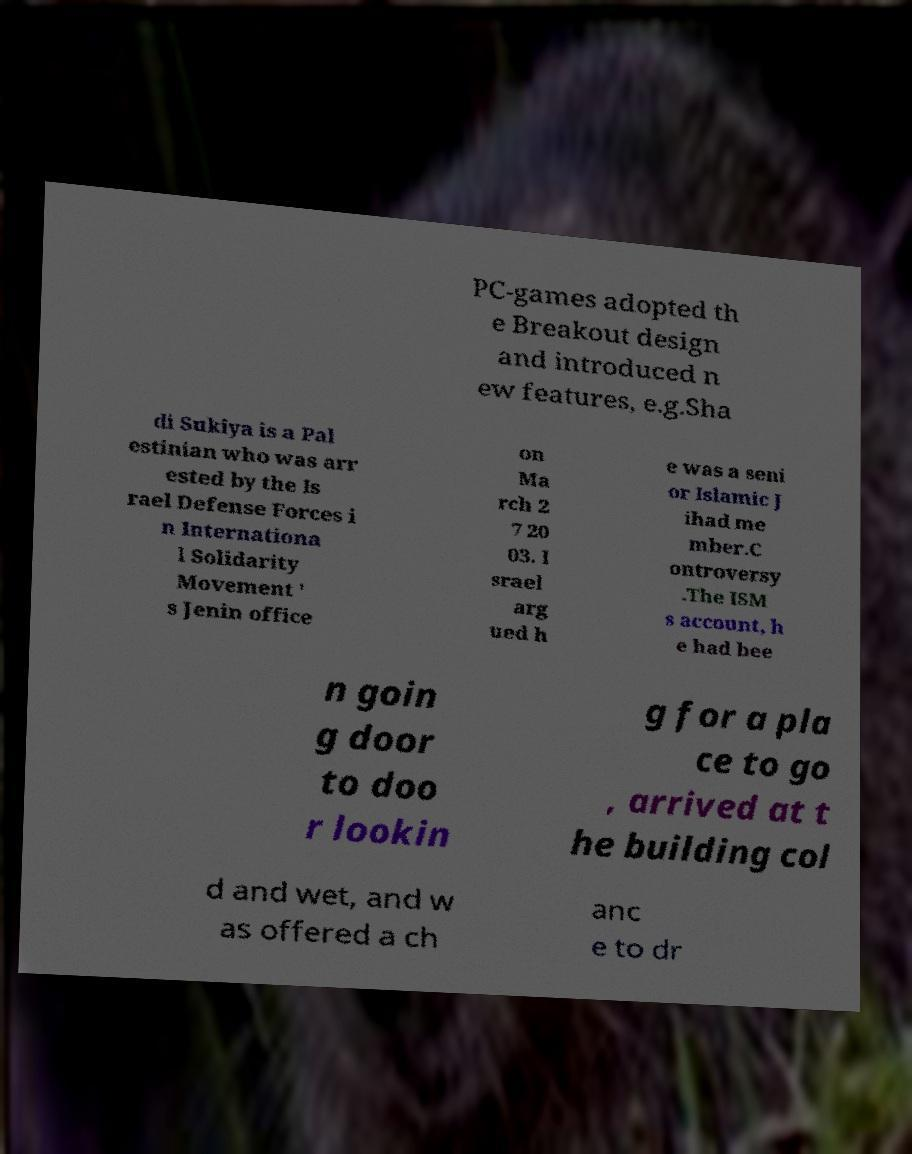What messages or text are displayed in this image? I need them in a readable, typed format. PC-games adopted th e Breakout design and introduced n ew features, e.g.Sha di Sukiya is a Pal estinian who was arr ested by the Is rael Defense Forces i n Internationa l Solidarity Movement ' s Jenin office on Ma rch 2 7 20 03. I srael arg ued h e was a seni or Islamic J ihad me mber.C ontroversy .The ISM s account, h e had bee n goin g door to doo r lookin g for a pla ce to go , arrived at t he building col d and wet, and w as offered a ch anc e to dr 